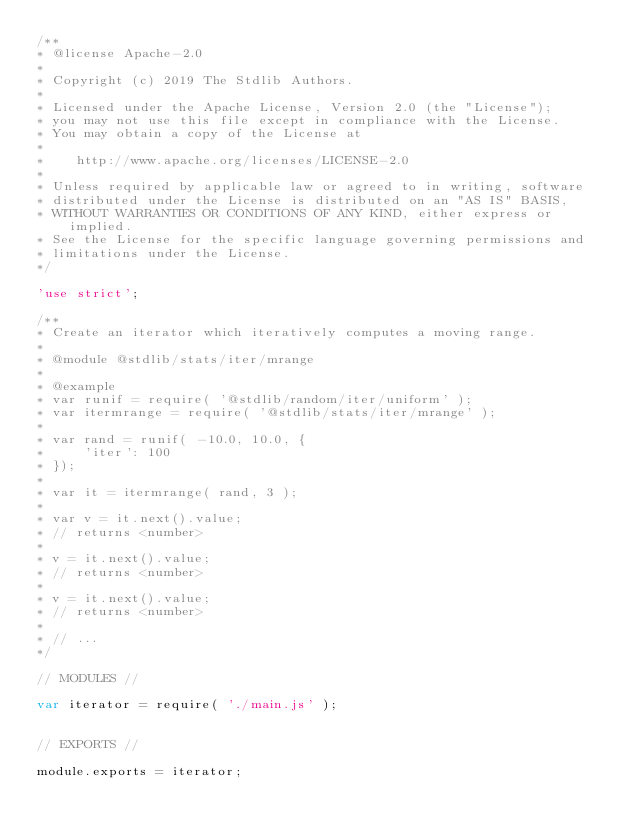<code> <loc_0><loc_0><loc_500><loc_500><_JavaScript_>/**
* @license Apache-2.0
*
* Copyright (c) 2019 The Stdlib Authors.
*
* Licensed under the Apache License, Version 2.0 (the "License");
* you may not use this file except in compliance with the License.
* You may obtain a copy of the License at
*
*    http://www.apache.org/licenses/LICENSE-2.0
*
* Unless required by applicable law or agreed to in writing, software
* distributed under the License is distributed on an "AS IS" BASIS,
* WITHOUT WARRANTIES OR CONDITIONS OF ANY KIND, either express or implied.
* See the License for the specific language governing permissions and
* limitations under the License.
*/

'use strict';

/**
* Create an iterator which iteratively computes a moving range.
*
* @module @stdlib/stats/iter/mrange
*
* @example
* var runif = require( '@stdlib/random/iter/uniform' );
* var itermrange = require( '@stdlib/stats/iter/mrange' );
*
* var rand = runif( -10.0, 10.0, {
*     'iter': 100
* });
*
* var it = itermrange( rand, 3 );
*
* var v = it.next().value;
* // returns <number>
*
* v = it.next().value;
* // returns <number>
*
* v = it.next().value;
* // returns <number>
*
* // ...
*/

// MODULES //

var iterator = require( './main.js' );


// EXPORTS //

module.exports = iterator;
</code> 